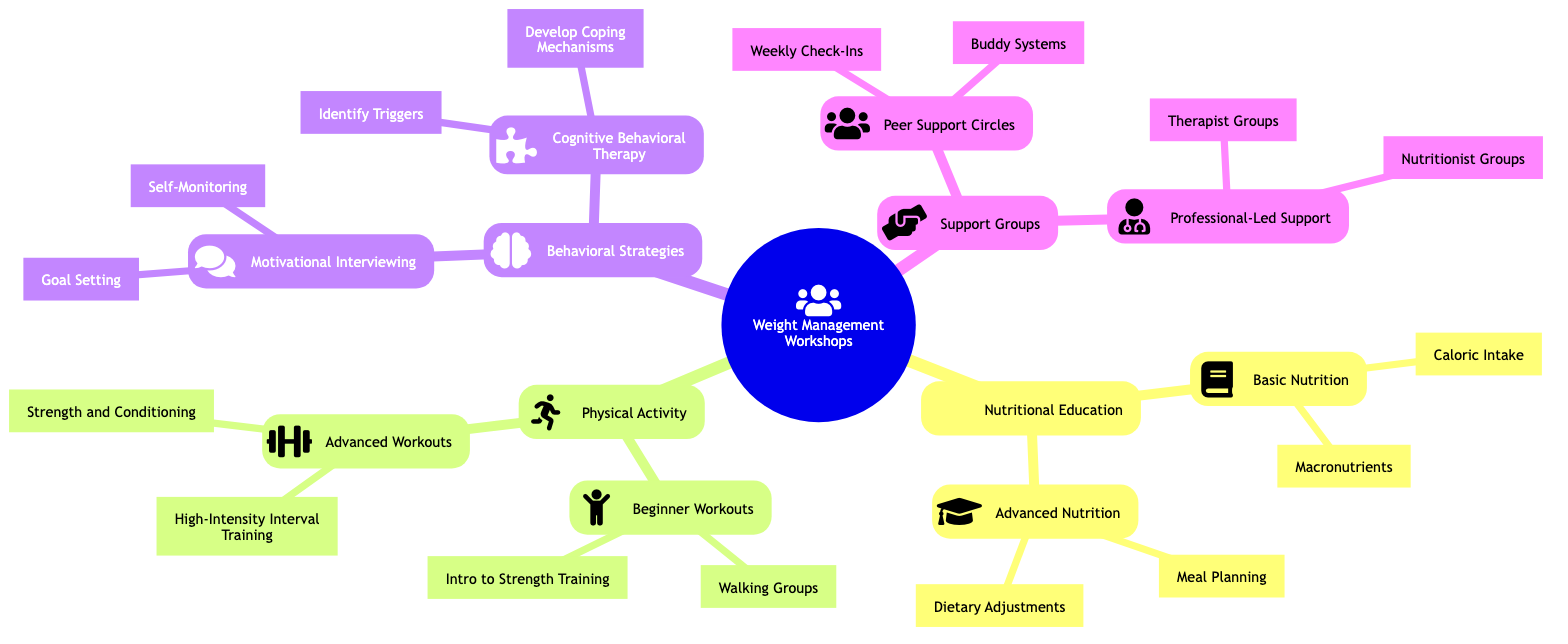What are the four main categories of workshops? The diagram shows four main categories of workshops under "Weight Management Workshops," which are "Nutritional Education," "Physical Activity," "Behavioral Strategies," and "Support Groups."
Answer: Nutritional Education, Physical Activity, Behavioral Strategies, Support Groups Which workshop provides immediate understanding? The "Basic Nutrition" workshop under "Nutritional Education" is specified to provide "Immediate Understanding."
Answer: Basic Nutrition How many subtopics are under "Basic Nutrition"? "Basic Nutrition" has two subtopics listed, which are "Caloric Intake" and "Macronutrients." Counting these gives a total of 2 subtopics.
Answer: 2 What is the impact over time of "Cognitive Behavioral Therapy"? The diagram indicates that "Cognitive Behavioral Therapy" leads to a "Long-Term Strategy Shift."
Answer: Long-Term Strategy Shift Which type of support group offers immediate emotional support? "Peer Support Circles" is identified in the diagram as providing "Immediate Emotional Support" under "Support Groups."
Answer: Peer Support Circles In which workshop would you find "Dietary Adjustments"? "Dietary Adjustments" falls under the "Advanced Nutrition" workshop, which is categorized under "Nutritional Education." This requires tracing from the main category to the subcategory.
Answer: Advanced Nutrition What is the impact over time of "Goal Setting"? The diagram states that "Goal Setting," a component of "Motivational Interviewing," has a "Short-Term Effect."
Answer: Short-Term Effect Which two workshops have the impact of "Medium-Term Effect"? "Meal Planning" and "High-Intensity Interval Training" are the workshops that possess "Medium-Term Effect" impacts when traced through the diagram.
Answer: Meal Planning, High-Intensity Interval Training How are “Weekly Check-Ins” and “Buddy Systems” related? Both "Weekly Check-Ins" and "Buddy Systems" are subtopics under the "Peer Support Circles," indicating they are part of the same support group category.
Answer: Peer Support Circles 